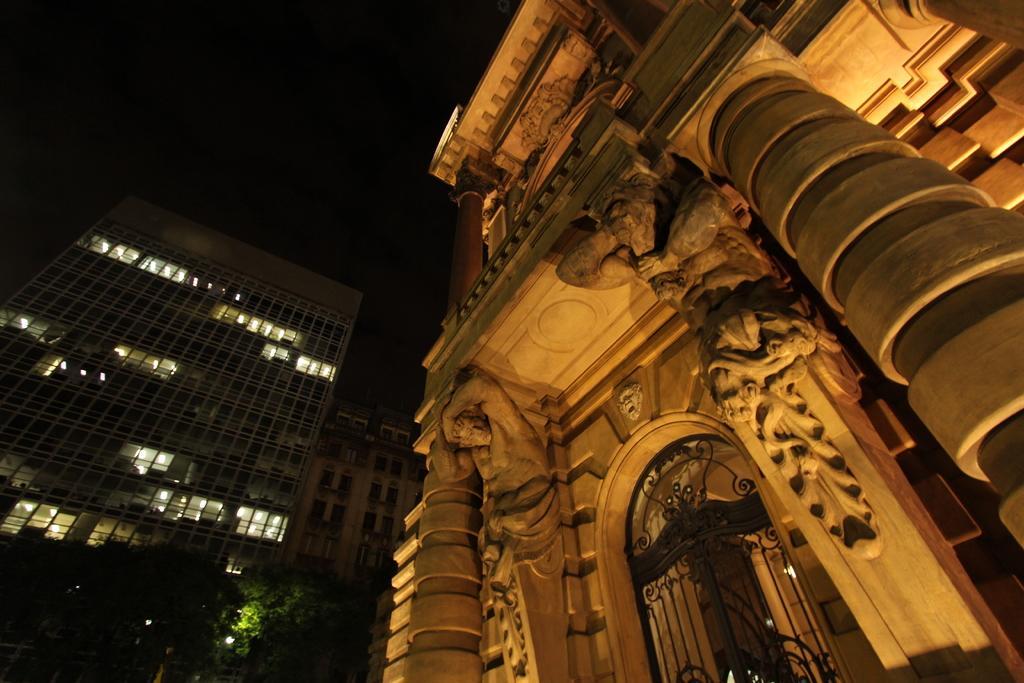Please provide a concise description of this image. In this image we can see statues on the building, grilled gate, buildings, trees and sky. 